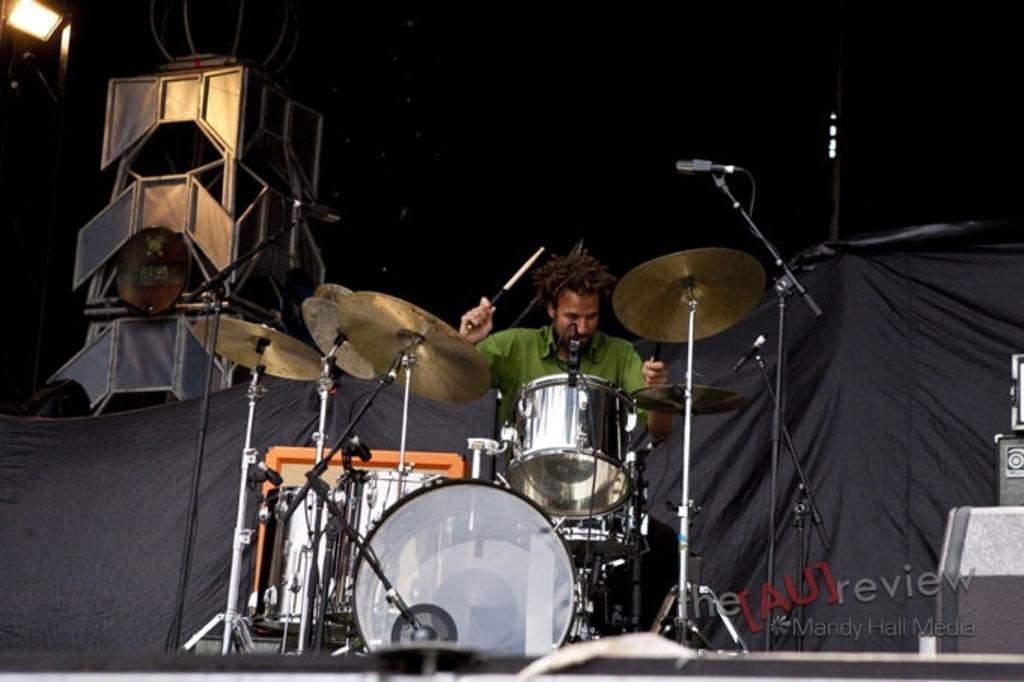Describe this image in one or two sentences. In the center of the image we can see a man is sitting and playing the musical instruments. In the background of the image we can see the cloth. On the left side of the image we can see a stand and light. On the right side of the image we can see a light and speakers. In the bottom right corner we can see the text. At the top, the image is dark. 